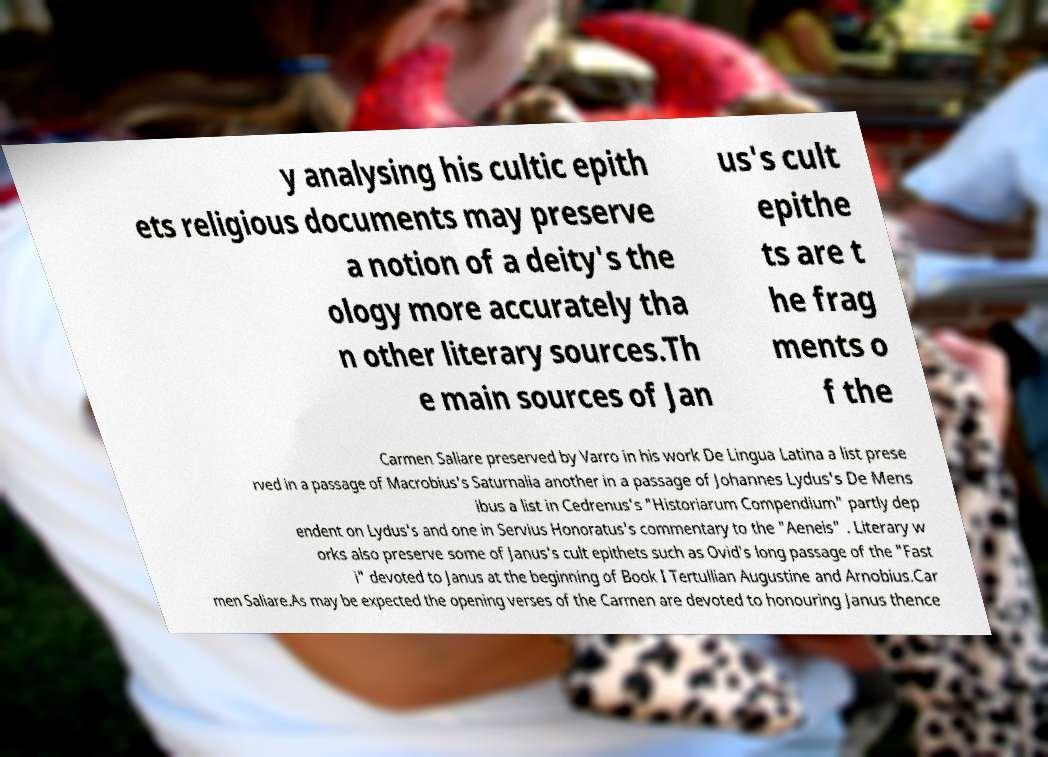Could you assist in decoding the text presented in this image and type it out clearly? y analysing his cultic epith ets religious documents may preserve a notion of a deity's the ology more accurately tha n other literary sources.Th e main sources of Jan us's cult epithe ts are t he frag ments o f the Carmen Saliare preserved by Varro in his work De Lingua Latina a list prese rved in a passage of Macrobius's Saturnalia another in a passage of Johannes Lydus's De Mens ibus a list in Cedrenus's "Historiarum Compendium" partly dep endent on Lydus's and one in Servius Honoratus's commentary to the "Aeneis" . Literary w orks also preserve some of Janus's cult epithets such as Ovid's long passage of the "Fast i" devoted to Janus at the beginning of Book I Tertullian Augustine and Arnobius.Car men Saliare.As may be expected the opening verses of the Carmen are devoted to honouring Janus thence 